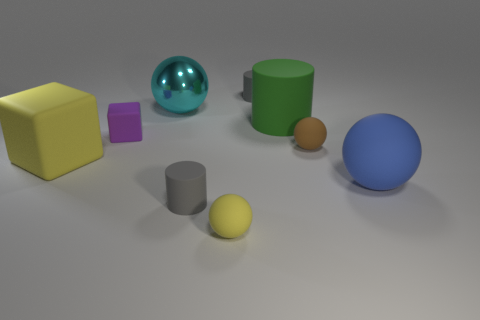Subtract all yellow matte balls. How many balls are left? 3 Add 1 gray matte cylinders. How many objects exist? 10 Subtract all green cylinders. How many cylinders are left? 2 Subtract all spheres. How many objects are left? 5 Subtract 1 cylinders. How many cylinders are left? 2 Subtract all purple blocks. How many brown cylinders are left? 0 Subtract all gray matte cylinders. Subtract all tiny purple cubes. How many objects are left? 6 Add 5 big cyan metallic things. How many big cyan metallic things are left? 6 Add 2 big rubber things. How many big rubber things exist? 5 Subtract 0 purple balls. How many objects are left? 9 